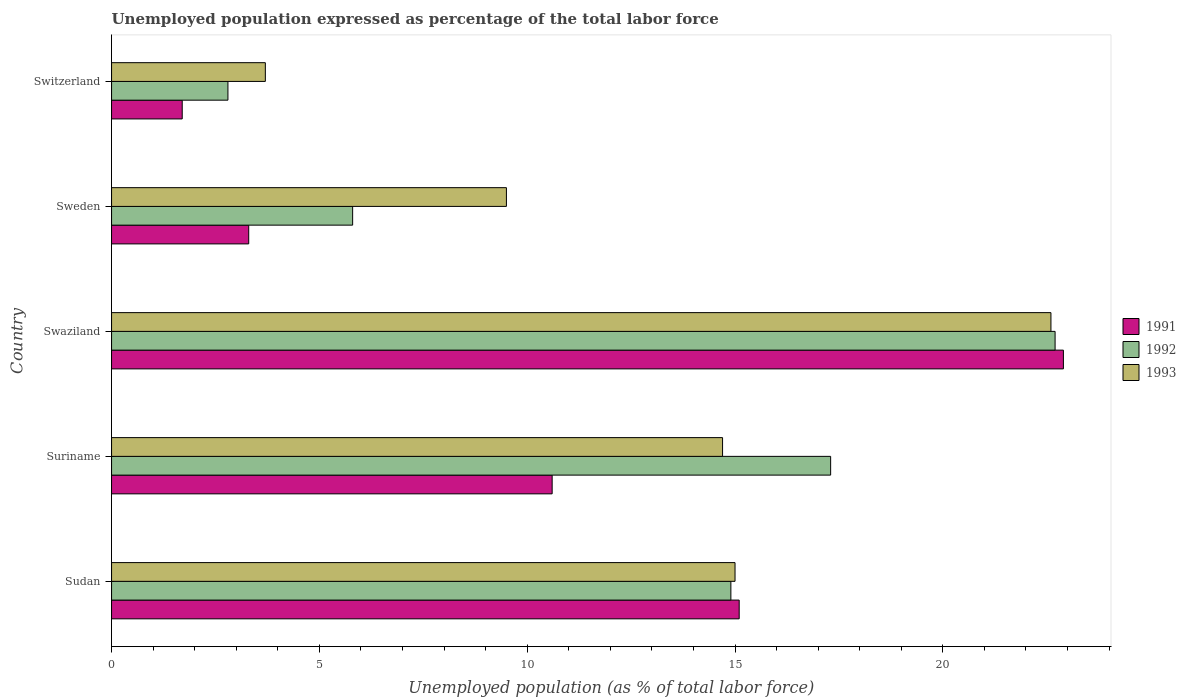How many groups of bars are there?
Offer a very short reply. 5. Are the number of bars per tick equal to the number of legend labels?
Your answer should be very brief. Yes. What is the label of the 5th group of bars from the top?
Offer a terse response. Sudan. In how many cases, is the number of bars for a given country not equal to the number of legend labels?
Ensure brevity in your answer.  0. What is the unemployment in in 1991 in Switzerland?
Keep it short and to the point. 1.7. Across all countries, what is the maximum unemployment in in 1991?
Provide a short and direct response. 22.9. Across all countries, what is the minimum unemployment in in 1991?
Your response must be concise. 1.7. In which country was the unemployment in in 1993 maximum?
Make the answer very short. Swaziland. In which country was the unemployment in in 1991 minimum?
Provide a short and direct response. Switzerland. What is the total unemployment in in 1993 in the graph?
Offer a terse response. 65.5. What is the difference between the unemployment in in 1993 in Sudan and that in Suriname?
Keep it short and to the point. 0.3. What is the difference between the unemployment in in 1993 in Suriname and the unemployment in in 1992 in Sweden?
Provide a short and direct response. 8.9. What is the average unemployment in in 1993 per country?
Your answer should be compact. 13.1. What is the difference between the unemployment in in 1993 and unemployment in in 1991 in Swaziland?
Your answer should be very brief. -0.3. In how many countries, is the unemployment in in 1992 greater than 9 %?
Ensure brevity in your answer.  3. What is the ratio of the unemployment in in 1993 in Suriname to that in Swaziland?
Ensure brevity in your answer.  0.65. Is the unemployment in in 1992 in Suriname less than that in Switzerland?
Keep it short and to the point. No. Is the difference between the unemployment in in 1993 in Sweden and Switzerland greater than the difference between the unemployment in in 1991 in Sweden and Switzerland?
Provide a short and direct response. Yes. What is the difference between the highest and the second highest unemployment in in 1993?
Offer a very short reply. 7.6. What is the difference between the highest and the lowest unemployment in in 1992?
Make the answer very short. 19.9. In how many countries, is the unemployment in in 1993 greater than the average unemployment in in 1993 taken over all countries?
Keep it short and to the point. 3. Is the sum of the unemployment in in 1992 in Suriname and Swaziland greater than the maximum unemployment in in 1993 across all countries?
Ensure brevity in your answer.  Yes. Is it the case that in every country, the sum of the unemployment in in 1992 and unemployment in in 1993 is greater than the unemployment in in 1991?
Make the answer very short. Yes. Are all the bars in the graph horizontal?
Provide a short and direct response. Yes. What is the difference between two consecutive major ticks on the X-axis?
Ensure brevity in your answer.  5. Are the values on the major ticks of X-axis written in scientific E-notation?
Offer a very short reply. No. Does the graph contain grids?
Give a very brief answer. No. Where does the legend appear in the graph?
Offer a terse response. Center right. How many legend labels are there?
Keep it short and to the point. 3. What is the title of the graph?
Offer a terse response. Unemployed population expressed as percentage of the total labor force. What is the label or title of the X-axis?
Give a very brief answer. Unemployed population (as % of total labor force). What is the label or title of the Y-axis?
Keep it short and to the point. Country. What is the Unemployed population (as % of total labor force) of 1991 in Sudan?
Provide a succinct answer. 15.1. What is the Unemployed population (as % of total labor force) in 1992 in Sudan?
Your response must be concise. 14.9. What is the Unemployed population (as % of total labor force) of 1993 in Sudan?
Your answer should be very brief. 15. What is the Unemployed population (as % of total labor force) of 1991 in Suriname?
Keep it short and to the point. 10.6. What is the Unemployed population (as % of total labor force) of 1992 in Suriname?
Keep it short and to the point. 17.3. What is the Unemployed population (as % of total labor force) of 1993 in Suriname?
Offer a terse response. 14.7. What is the Unemployed population (as % of total labor force) of 1991 in Swaziland?
Give a very brief answer. 22.9. What is the Unemployed population (as % of total labor force) of 1992 in Swaziland?
Provide a short and direct response. 22.7. What is the Unemployed population (as % of total labor force) of 1993 in Swaziland?
Keep it short and to the point. 22.6. What is the Unemployed population (as % of total labor force) in 1991 in Sweden?
Ensure brevity in your answer.  3.3. What is the Unemployed population (as % of total labor force) in 1992 in Sweden?
Make the answer very short. 5.8. What is the Unemployed population (as % of total labor force) of 1993 in Sweden?
Make the answer very short. 9.5. What is the Unemployed population (as % of total labor force) of 1991 in Switzerland?
Offer a terse response. 1.7. What is the Unemployed population (as % of total labor force) of 1992 in Switzerland?
Ensure brevity in your answer.  2.8. What is the Unemployed population (as % of total labor force) of 1993 in Switzerland?
Your answer should be very brief. 3.7. Across all countries, what is the maximum Unemployed population (as % of total labor force) in 1991?
Provide a short and direct response. 22.9. Across all countries, what is the maximum Unemployed population (as % of total labor force) of 1992?
Keep it short and to the point. 22.7. Across all countries, what is the maximum Unemployed population (as % of total labor force) in 1993?
Offer a very short reply. 22.6. Across all countries, what is the minimum Unemployed population (as % of total labor force) in 1991?
Provide a succinct answer. 1.7. Across all countries, what is the minimum Unemployed population (as % of total labor force) in 1992?
Your answer should be very brief. 2.8. Across all countries, what is the minimum Unemployed population (as % of total labor force) in 1993?
Your answer should be compact. 3.7. What is the total Unemployed population (as % of total labor force) of 1991 in the graph?
Your response must be concise. 53.6. What is the total Unemployed population (as % of total labor force) in 1992 in the graph?
Make the answer very short. 63.5. What is the total Unemployed population (as % of total labor force) in 1993 in the graph?
Provide a succinct answer. 65.5. What is the difference between the Unemployed population (as % of total labor force) in 1992 in Sudan and that in Switzerland?
Offer a terse response. 12.1. What is the difference between the Unemployed population (as % of total labor force) in 1993 in Sudan and that in Switzerland?
Offer a very short reply. 11.3. What is the difference between the Unemployed population (as % of total labor force) in 1992 in Suriname and that in Sweden?
Your response must be concise. 11.5. What is the difference between the Unemployed population (as % of total labor force) of 1992 in Suriname and that in Switzerland?
Ensure brevity in your answer.  14.5. What is the difference between the Unemployed population (as % of total labor force) of 1993 in Suriname and that in Switzerland?
Offer a terse response. 11. What is the difference between the Unemployed population (as % of total labor force) in 1991 in Swaziland and that in Sweden?
Your answer should be very brief. 19.6. What is the difference between the Unemployed population (as % of total labor force) in 1992 in Swaziland and that in Sweden?
Your response must be concise. 16.9. What is the difference between the Unemployed population (as % of total labor force) in 1991 in Swaziland and that in Switzerland?
Ensure brevity in your answer.  21.2. What is the difference between the Unemployed population (as % of total labor force) in 1992 in Sweden and that in Switzerland?
Offer a very short reply. 3. What is the difference between the Unemployed population (as % of total labor force) in 1993 in Sweden and that in Switzerland?
Offer a very short reply. 5.8. What is the difference between the Unemployed population (as % of total labor force) of 1991 in Sudan and the Unemployed population (as % of total labor force) of 1993 in Swaziland?
Make the answer very short. -7.5. What is the difference between the Unemployed population (as % of total labor force) of 1992 in Sudan and the Unemployed population (as % of total labor force) of 1993 in Swaziland?
Give a very brief answer. -7.7. What is the difference between the Unemployed population (as % of total labor force) of 1991 in Sudan and the Unemployed population (as % of total labor force) of 1992 in Switzerland?
Keep it short and to the point. 12.3. What is the difference between the Unemployed population (as % of total labor force) in 1992 in Suriname and the Unemployed population (as % of total labor force) in 1993 in Swaziland?
Keep it short and to the point. -5.3. What is the difference between the Unemployed population (as % of total labor force) in 1991 in Suriname and the Unemployed population (as % of total labor force) in 1992 in Sweden?
Keep it short and to the point. 4.8. What is the difference between the Unemployed population (as % of total labor force) of 1991 in Suriname and the Unemployed population (as % of total labor force) of 1993 in Sweden?
Make the answer very short. 1.1. What is the difference between the Unemployed population (as % of total labor force) in 1991 in Suriname and the Unemployed population (as % of total labor force) in 1993 in Switzerland?
Your answer should be compact. 6.9. What is the difference between the Unemployed population (as % of total labor force) in 1992 in Suriname and the Unemployed population (as % of total labor force) in 1993 in Switzerland?
Your answer should be compact. 13.6. What is the difference between the Unemployed population (as % of total labor force) in 1992 in Swaziland and the Unemployed population (as % of total labor force) in 1993 in Sweden?
Keep it short and to the point. 13.2. What is the difference between the Unemployed population (as % of total labor force) in 1991 in Swaziland and the Unemployed population (as % of total labor force) in 1992 in Switzerland?
Give a very brief answer. 20.1. What is the difference between the Unemployed population (as % of total labor force) of 1991 in Swaziland and the Unemployed population (as % of total labor force) of 1993 in Switzerland?
Your response must be concise. 19.2. What is the difference between the Unemployed population (as % of total labor force) of 1992 in Swaziland and the Unemployed population (as % of total labor force) of 1993 in Switzerland?
Provide a succinct answer. 19. What is the difference between the Unemployed population (as % of total labor force) of 1992 in Sweden and the Unemployed population (as % of total labor force) of 1993 in Switzerland?
Give a very brief answer. 2.1. What is the average Unemployed population (as % of total labor force) in 1991 per country?
Make the answer very short. 10.72. What is the average Unemployed population (as % of total labor force) of 1993 per country?
Provide a succinct answer. 13.1. What is the difference between the Unemployed population (as % of total labor force) in 1991 and Unemployed population (as % of total labor force) in 1992 in Suriname?
Your answer should be compact. -6.7. What is the difference between the Unemployed population (as % of total labor force) in 1991 and Unemployed population (as % of total labor force) in 1993 in Suriname?
Provide a short and direct response. -4.1. What is the difference between the Unemployed population (as % of total labor force) in 1992 and Unemployed population (as % of total labor force) in 1993 in Suriname?
Provide a short and direct response. 2.6. What is the difference between the Unemployed population (as % of total labor force) in 1991 and Unemployed population (as % of total labor force) in 1993 in Swaziland?
Ensure brevity in your answer.  0.3. What is the difference between the Unemployed population (as % of total labor force) of 1991 and Unemployed population (as % of total labor force) of 1993 in Sweden?
Provide a short and direct response. -6.2. What is the difference between the Unemployed population (as % of total labor force) of 1991 and Unemployed population (as % of total labor force) of 1992 in Switzerland?
Provide a succinct answer. -1.1. What is the difference between the Unemployed population (as % of total labor force) of 1991 and Unemployed population (as % of total labor force) of 1993 in Switzerland?
Offer a very short reply. -2. What is the difference between the Unemployed population (as % of total labor force) of 1992 and Unemployed population (as % of total labor force) of 1993 in Switzerland?
Give a very brief answer. -0.9. What is the ratio of the Unemployed population (as % of total labor force) in 1991 in Sudan to that in Suriname?
Make the answer very short. 1.42. What is the ratio of the Unemployed population (as % of total labor force) of 1992 in Sudan to that in Suriname?
Keep it short and to the point. 0.86. What is the ratio of the Unemployed population (as % of total labor force) of 1993 in Sudan to that in Suriname?
Provide a short and direct response. 1.02. What is the ratio of the Unemployed population (as % of total labor force) in 1991 in Sudan to that in Swaziland?
Keep it short and to the point. 0.66. What is the ratio of the Unemployed population (as % of total labor force) in 1992 in Sudan to that in Swaziland?
Make the answer very short. 0.66. What is the ratio of the Unemployed population (as % of total labor force) of 1993 in Sudan to that in Swaziland?
Keep it short and to the point. 0.66. What is the ratio of the Unemployed population (as % of total labor force) in 1991 in Sudan to that in Sweden?
Provide a short and direct response. 4.58. What is the ratio of the Unemployed population (as % of total labor force) in 1992 in Sudan to that in Sweden?
Make the answer very short. 2.57. What is the ratio of the Unemployed population (as % of total labor force) of 1993 in Sudan to that in Sweden?
Offer a very short reply. 1.58. What is the ratio of the Unemployed population (as % of total labor force) of 1991 in Sudan to that in Switzerland?
Keep it short and to the point. 8.88. What is the ratio of the Unemployed population (as % of total labor force) of 1992 in Sudan to that in Switzerland?
Offer a very short reply. 5.32. What is the ratio of the Unemployed population (as % of total labor force) in 1993 in Sudan to that in Switzerland?
Your answer should be compact. 4.05. What is the ratio of the Unemployed population (as % of total labor force) in 1991 in Suriname to that in Swaziland?
Your answer should be compact. 0.46. What is the ratio of the Unemployed population (as % of total labor force) of 1992 in Suriname to that in Swaziland?
Your response must be concise. 0.76. What is the ratio of the Unemployed population (as % of total labor force) in 1993 in Suriname to that in Swaziland?
Your answer should be very brief. 0.65. What is the ratio of the Unemployed population (as % of total labor force) of 1991 in Suriname to that in Sweden?
Make the answer very short. 3.21. What is the ratio of the Unemployed population (as % of total labor force) in 1992 in Suriname to that in Sweden?
Your response must be concise. 2.98. What is the ratio of the Unemployed population (as % of total labor force) of 1993 in Suriname to that in Sweden?
Ensure brevity in your answer.  1.55. What is the ratio of the Unemployed population (as % of total labor force) of 1991 in Suriname to that in Switzerland?
Ensure brevity in your answer.  6.24. What is the ratio of the Unemployed population (as % of total labor force) in 1992 in Suriname to that in Switzerland?
Provide a short and direct response. 6.18. What is the ratio of the Unemployed population (as % of total labor force) of 1993 in Suriname to that in Switzerland?
Ensure brevity in your answer.  3.97. What is the ratio of the Unemployed population (as % of total labor force) of 1991 in Swaziland to that in Sweden?
Keep it short and to the point. 6.94. What is the ratio of the Unemployed population (as % of total labor force) in 1992 in Swaziland to that in Sweden?
Ensure brevity in your answer.  3.91. What is the ratio of the Unemployed population (as % of total labor force) of 1993 in Swaziland to that in Sweden?
Your response must be concise. 2.38. What is the ratio of the Unemployed population (as % of total labor force) in 1991 in Swaziland to that in Switzerland?
Provide a succinct answer. 13.47. What is the ratio of the Unemployed population (as % of total labor force) in 1992 in Swaziland to that in Switzerland?
Offer a terse response. 8.11. What is the ratio of the Unemployed population (as % of total labor force) in 1993 in Swaziland to that in Switzerland?
Make the answer very short. 6.11. What is the ratio of the Unemployed population (as % of total labor force) of 1991 in Sweden to that in Switzerland?
Offer a terse response. 1.94. What is the ratio of the Unemployed population (as % of total labor force) in 1992 in Sweden to that in Switzerland?
Give a very brief answer. 2.07. What is the ratio of the Unemployed population (as % of total labor force) of 1993 in Sweden to that in Switzerland?
Your response must be concise. 2.57. What is the difference between the highest and the second highest Unemployed population (as % of total labor force) of 1993?
Your answer should be very brief. 7.6. What is the difference between the highest and the lowest Unemployed population (as % of total labor force) of 1991?
Your response must be concise. 21.2. What is the difference between the highest and the lowest Unemployed population (as % of total labor force) in 1993?
Offer a very short reply. 18.9. 